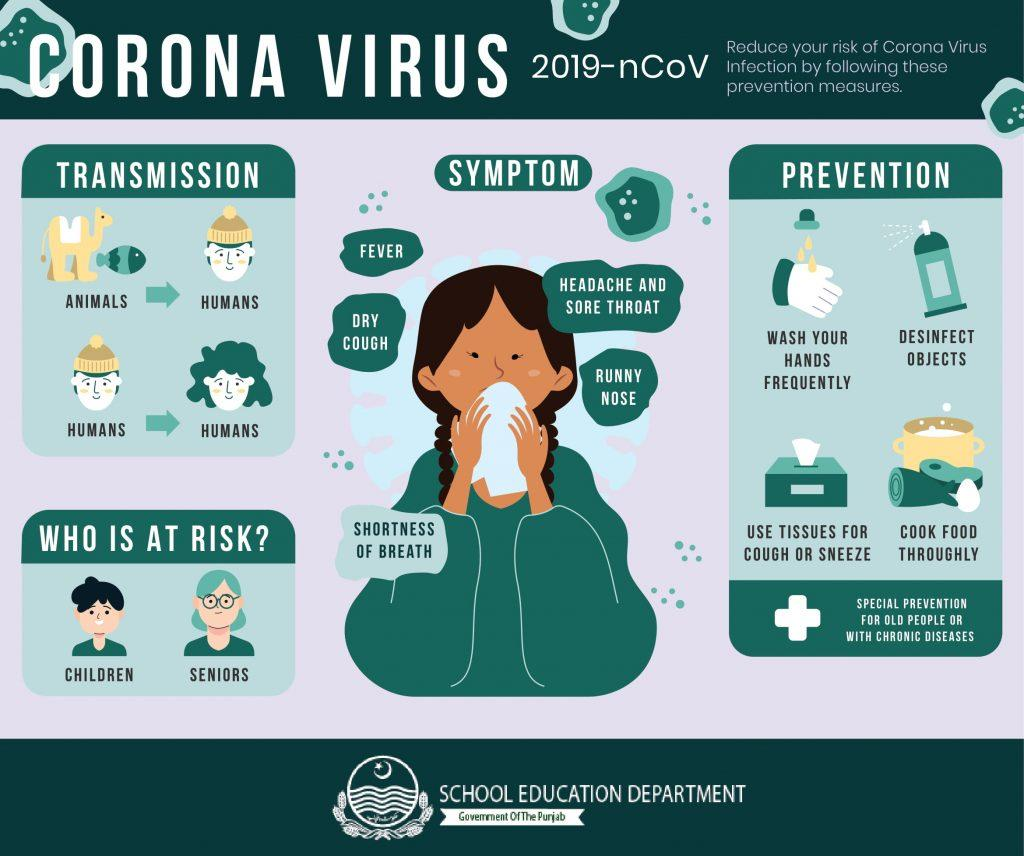Give some essential details in this illustration. The number of people shown in the infographic is six. 